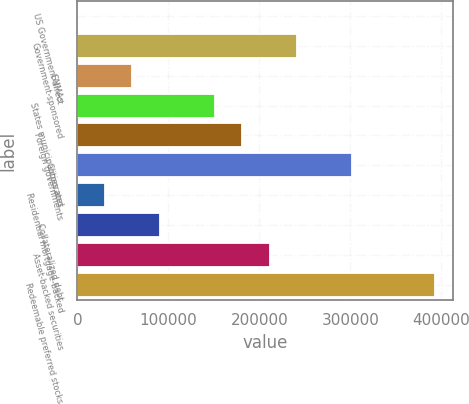Convert chart. <chart><loc_0><loc_0><loc_500><loc_500><bar_chart><fcel>US Government direct<fcel>Government-sponsored<fcel>GNMAs<fcel>States municipalities and<fcel>Foreign governments<fcel>Corporates<fcel>Residential mortgage-backed<fcel>Collateralized debt<fcel>Asset-backed securities<fcel>Redeemable preferred stocks<nl><fcel>0.39<fcel>241616<fcel>60404.3<fcel>151010<fcel>181212<fcel>302020<fcel>30202.3<fcel>90606.3<fcel>211414<fcel>392626<nl></chart> 